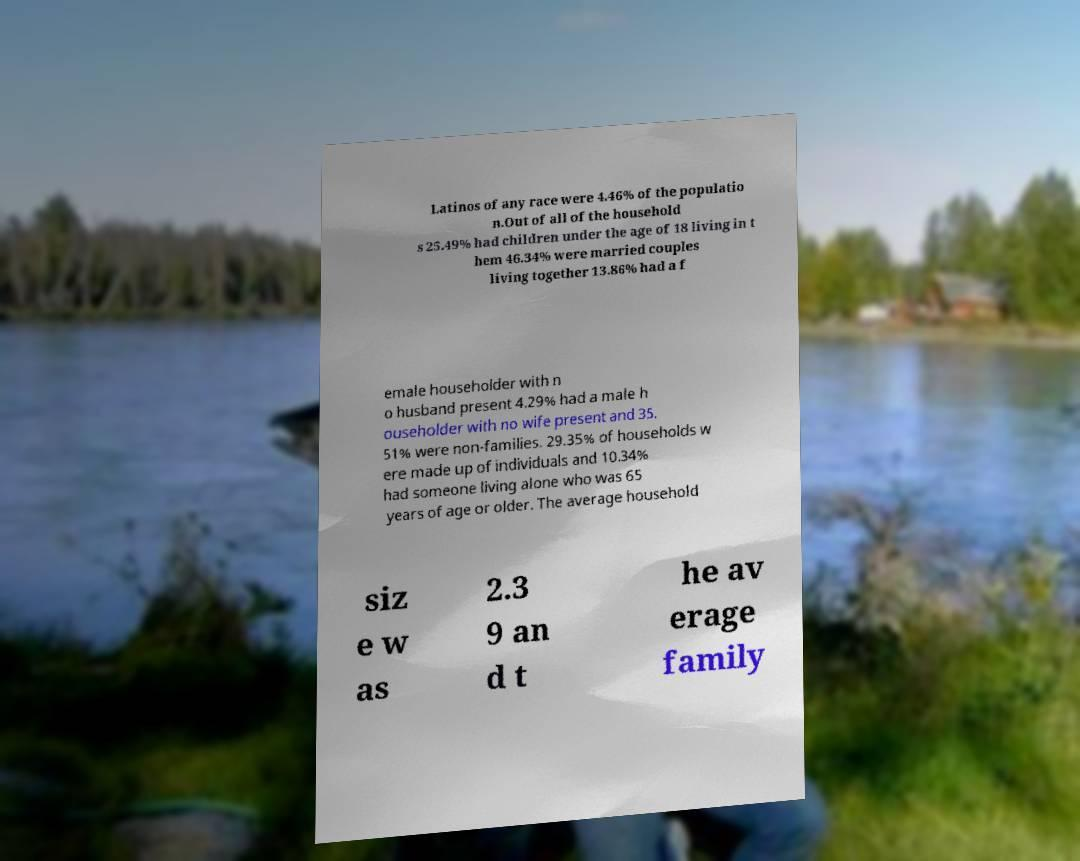Can you read and provide the text displayed in the image?This photo seems to have some interesting text. Can you extract and type it out for me? Latinos of any race were 4.46% of the populatio n.Out of all of the household s 25.49% had children under the age of 18 living in t hem 46.34% were married couples living together 13.86% had a f emale householder with n o husband present 4.29% had a male h ouseholder with no wife present and 35. 51% were non-families. 29.35% of households w ere made up of individuals and 10.34% had someone living alone who was 65 years of age or older. The average household siz e w as 2.3 9 an d t he av erage family 